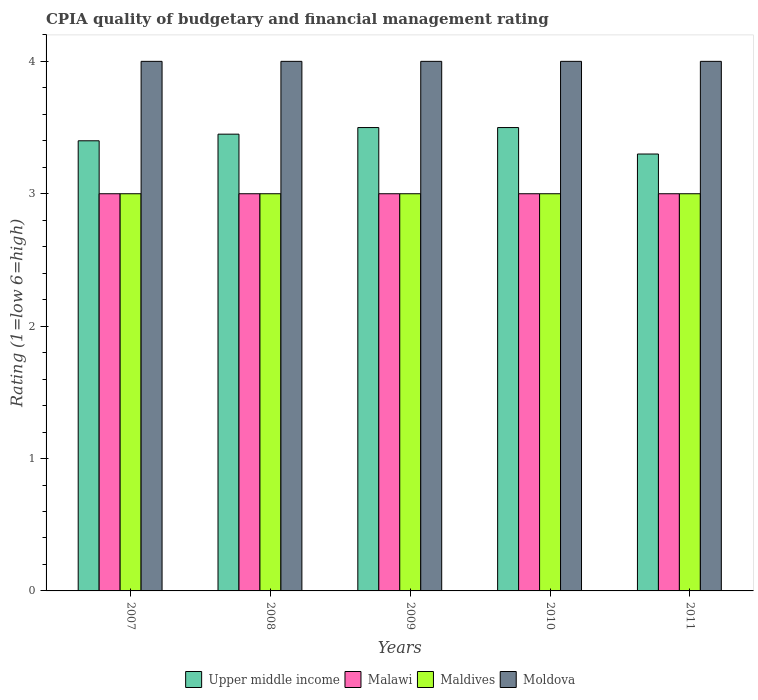Are the number of bars on each tick of the X-axis equal?
Ensure brevity in your answer.  Yes. How many bars are there on the 4th tick from the left?
Give a very brief answer. 4. Across all years, what is the maximum CPIA rating in Moldova?
Your answer should be compact. 4. In which year was the CPIA rating in Maldives maximum?
Offer a very short reply. 2007. In which year was the CPIA rating in Malawi minimum?
Make the answer very short. 2007. What is the difference between the CPIA rating in Maldives in 2008 and that in 2009?
Keep it short and to the point. 0. What is the average CPIA rating in Maldives per year?
Offer a terse response. 3. In how many years, is the CPIA rating in Maldives greater than 1?
Your answer should be very brief. 5. What is the difference between the highest and the lowest CPIA rating in Upper middle income?
Provide a succinct answer. 0.2. In how many years, is the CPIA rating in Moldova greater than the average CPIA rating in Moldova taken over all years?
Make the answer very short. 0. What does the 1st bar from the left in 2011 represents?
Your answer should be very brief. Upper middle income. What does the 4th bar from the right in 2011 represents?
Offer a terse response. Upper middle income. Are all the bars in the graph horizontal?
Your answer should be very brief. No. How many years are there in the graph?
Provide a short and direct response. 5. What is the difference between two consecutive major ticks on the Y-axis?
Offer a very short reply. 1. Does the graph contain any zero values?
Offer a very short reply. No. Does the graph contain grids?
Provide a succinct answer. No. Where does the legend appear in the graph?
Your response must be concise. Bottom center. How are the legend labels stacked?
Your response must be concise. Horizontal. What is the title of the graph?
Your response must be concise. CPIA quality of budgetary and financial management rating. Does "Luxembourg" appear as one of the legend labels in the graph?
Your answer should be compact. No. What is the Rating (1=low 6=high) in Maldives in 2007?
Your answer should be very brief. 3. What is the Rating (1=low 6=high) of Upper middle income in 2008?
Your answer should be compact. 3.45. What is the Rating (1=low 6=high) of Malawi in 2008?
Give a very brief answer. 3. What is the Rating (1=low 6=high) of Maldives in 2009?
Offer a very short reply. 3. What is the Rating (1=low 6=high) of Moldova in 2009?
Provide a succinct answer. 4. What is the Rating (1=low 6=high) of Malawi in 2010?
Offer a very short reply. 3. What is the Rating (1=low 6=high) of Maldives in 2010?
Offer a very short reply. 3. What is the Rating (1=low 6=high) of Moldova in 2010?
Give a very brief answer. 4. What is the Rating (1=low 6=high) in Upper middle income in 2011?
Offer a very short reply. 3.3. What is the Rating (1=low 6=high) of Maldives in 2011?
Your answer should be compact. 3. What is the Rating (1=low 6=high) in Moldova in 2011?
Your answer should be very brief. 4. Across all years, what is the maximum Rating (1=low 6=high) in Malawi?
Offer a terse response. 3. Across all years, what is the minimum Rating (1=low 6=high) of Upper middle income?
Offer a terse response. 3.3. Across all years, what is the minimum Rating (1=low 6=high) in Maldives?
Give a very brief answer. 3. What is the total Rating (1=low 6=high) of Upper middle income in the graph?
Provide a short and direct response. 17.15. What is the total Rating (1=low 6=high) of Malawi in the graph?
Provide a succinct answer. 15. What is the difference between the Rating (1=low 6=high) in Malawi in 2007 and that in 2008?
Keep it short and to the point. 0. What is the difference between the Rating (1=low 6=high) of Maldives in 2007 and that in 2008?
Ensure brevity in your answer.  0. What is the difference between the Rating (1=low 6=high) in Moldova in 2007 and that in 2008?
Provide a succinct answer. 0. What is the difference between the Rating (1=low 6=high) in Moldova in 2007 and that in 2009?
Your answer should be compact. 0. What is the difference between the Rating (1=low 6=high) in Upper middle income in 2007 and that in 2010?
Offer a terse response. -0.1. What is the difference between the Rating (1=low 6=high) in Malawi in 2007 and that in 2010?
Keep it short and to the point. 0. What is the difference between the Rating (1=low 6=high) in Maldives in 2007 and that in 2010?
Keep it short and to the point. 0. What is the difference between the Rating (1=low 6=high) in Moldova in 2007 and that in 2010?
Your answer should be compact. 0. What is the difference between the Rating (1=low 6=high) of Malawi in 2007 and that in 2011?
Your answer should be compact. 0. What is the difference between the Rating (1=low 6=high) of Moldova in 2007 and that in 2011?
Make the answer very short. 0. What is the difference between the Rating (1=low 6=high) in Malawi in 2008 and that in 2010?
Offer a very short reply. 0. What is the difference between the Rating (1=low 6=high) of Upper middle income in 2008 and that in 2011?
Give a very brief answer. 0.15. What is the difference between the Rating (1=low 6=high) in Malawi in 2008 and that in 2011?
Offer a terse response. 0. What is the difference between the Rating (1=low 6=high) in Maldives in 2008 and that in 2011?
Keep it short and to the point. 0. What is the difference between the Rating (1=low 6=high) in Maldives in 2009 and that in 2010?
Offer a very short reply. 0. What is the difference between the Rating (1=low 6=high) in Moldova in 2009 and that in 2010?
Keep it short and to the point. 0. What is the difference between the Rating (1=low 6=high) of Upper middle income in 2009 and that in 2011?
Give a very brief answer. 0.2. What is the difference between the Rating (1=low 6=high) of Malawi in 2009 and that in 2011?
Make the answer very short. 0. What is the difference between the Rating (1=low 6=high) in Maldives in 2009 and that in 2011?
Your answer should be very brief. 0. What is the difference between the Rating (1=low 6=high) in Moldova in 2009 and that in 2011?
Make the answer very short. 0. What is the difference between the Rating (1=low 6=high) in Maldives in 2010 and that in 2011?
Keep it short and to the point. 0. What is the difference between the Rating (1=low 6=high) of Upper middle income in 2007 and the Rating (1=low 6=high) of Malawi in 2008?
Your answer should be very brief. 0.4. What is the difference between the Rating (1=low 6=high) of Upper middle income in 2007 and the Rating (1=low 6=high) of Moldova in 2009?
Your answer should be compact. -0.6. What is the difference between the Rating (1=low 6=high) in Maldives in 2007 and the Rating (1=low 6=high) in Moldova in 2009?
Your answer should be very brief. -1. What is the difference between the Rating (1=low 6=high) of Upper middle income in 2007 and the Rating (1=low 6=high) of Maldives in 2010?
Your answer should be compact. 0.4. What is the difference between the Rating (1=low 6=high) of Upper middle income in 2007 and the Rating (1=low 6=high) of Malawi in 2011?
Make the answer very short. 0.4. What is the difference between the Rating (1=low 6=high) in Malawi in 2007 and the Rating (1=low 6=high) in Moldova in 2011?
Offer a very short reply. -1. What is the difference between the Rating (1=low 6=high) of Upper middle income in 2008 and the Rating (1=low 6=high) of Malawi in 2009?
Offer a terse response. 0.45. What is the difference between the Rating (1=low 6=high) of Upper middle income in 2008 and the Rating (1=low 6=high) of Maldives in 2009?
Your response must be concise. 0.45. What is the difference between the Rating (1=low 6=high) of Upper middle income in 2008 and the Rating (1=low 6=high) of Moldova in 2009?
Keep it short and to the point. -0.55. What is the difference between the Rating (1=low 6=high) in Malawi in 2008 and the Rating (1=low 6=high) in Maldives in 2009?
Offer a very short reply. 0. What is the difference between the Rating (1=low 6=high) of Upper middle income in 2008 and the Rating (1=low 6=high) of Malawi in 2010?
Ensure brevity in your answer.  0.45. What is the difference between the Rating (1=low 6=high) of Upper middle income in 2008 and the Rating (1=low 6=high) of Maldives in 2010?
Provide a short and direct response. 0.45. What is the difference between the Rating (1=low 6=high) of Upper middle income in 2008 and the Rating (1=low 6=high) of Moldova in 2010?
Provide a succinct answer. -0.55. What is the difference between the Rating (1=low 6=high) of Malawi in 2008 and the Rating (1=low 6=high) of Maldives in 2010?
Provide a succinct answer. 0. What is the difference between the Rating (1=low 6=high) in Malawi in 2008 and the Rating (1=low 6=high) in Moldova in 2010?
Provide a short and direct response. -1. What is the difference between the Rating (1=low 6=high) in Upper middle income in 2008 and the Rating (1=low 6=high) in Malawi in 2011?
Keep it short and to the point. 0.45. What is the difference between the Rating (1=low 6=high) in Upper middle income in 2008 and the Rating (1=low 6=high) in Maldives in 2011?
Your answer should be compact. 0.45. What is the difference between the Rating (1=low 6=high) of Upper middle income in 2008 and the Rating (1=low 6=high) of Moldova in 2011?
Your answer should be very brief. -0.55. What is the difference between the Rating (1=low 6=high) of Malawi in 2008 and the Rating (1=low 6=high) of Maldives in 2011?
Keep it short and to the point. 0. What is the difference between the Rating (1=low 6=high) in Malawi in 2008 and the Rating (1=low 6=high) in Moldova in 2011?
Provide a succinct answer. -1. What is the difference between the Rating (1=low 6=high) in Maldives in 2008 and the Rating (1=low 6=high) in Moldova in 2011?
Your answer should be compact. -1. What is the difference between the Rating (1=low 6=high) in Upper middle income in 2009 and the Rating (1=low 6=high) in Malawi in 2010?
Your answer should be very brief. 0.5. What is the difference between the Rating (1=low 6=high) of Malawi in 2009 and the Rating (1=low 6=high) of Moldova in 2010?
Your response must be concise. -1. What is the difference between the Rating (1=low 6=high) of Upper middle income in 2009 and the Rating (1=low 6=high) of Moldova in 2011?
Provide a succinct answer. -0.5. What is the difference between the Rating (1=low 6=high) in Maldives in 2009 and the Rating (1=low 6=high) in Moldova in 2011?
Keep it short and to the point. -1. What is the difference between the Rating (1=low 6=high) of Upper middle income in 2010 and the Rating (1=low 6=high) of Malawi in 2011?
Provide a short and direct response. 0.5. What is the difference between the Rating (1=low 6=high) of Malawi in 2010 and the Rating (1=low 6=high) of Maldives in 2011?
Make the answer very short. 0. What is the difference between the Rating (1=low 6=high) of Malawi in 2010 and the Rating (1=low 6=high) of Moldova in 2011?
Make the answer very short. -1. What is the average Rating (1=low 6=high) in Upper middle income per year?
Your answer should be very brief. 3.43. What is the average Rating (1=low 6=high) of Maldives per year?
Offer a terse response. 3. In the year 2007, what is the difference between the Rating (1=low 6=high) of Upper middle income and Rating (1=low 6=high) of Malawi?
Provide a short and direct response. 0.4. In the year 2007, what is the difference between the Rating (1=low 6=high) in Upper middle income and Rating (1=low 6=high) in Maldives?
Give a very brief answer. 0.4. In the year 2007, what is the difference between the Rating (1=low 6=high) in Malawi and Rating (1=low 6=high) in Maldives?
Keep it short and to the point. 0. In the year 2007, what is the difference between the Rating (1=low 6=high) in Malawi and Rating (1=low 6=high) in Moldova?
Provide a short and direct response. -1. In the year 2007, what is the difference between the Rating (1=low 6=high) in Maldives and Rating (1=low 6=high) in Moldova?
Provide a short and direct response. -1. In the year 2008, what is the difference between the Rating (1=low 6=high) of Upper middle income and Rating (1=low 6=high) of Malawi?
Your answer should be very brief. 0.45. In the year 2008, what is the difference between the Rating (1=low 6=high) of Upper middle income and Rating (1=low 6=high) of Maldives?
Keep it short and to the point. 0.45. In the year 2008, what is the difference between the Rating (1=low 6=high) of Upper middle income and Rating (1=low 6=high) of Moldova?
Give a very brief answer. -0.55. In the year 2008, what is the difference between the Rating (1=low 6=high) of Malawi and Rating (1=low 6=high) of Maldives?
Offer a very short reply. 0. In the year 2008, what is the difference between the Rating (1=low 6=high) of Maldives and Rating (1=low 6=high) of Moldova?
Offer a very short reply. -1. In the year 2009, what is the difference between the Rating (1=low 6=high) in Malawi and Rating (1=low 6=high) in Moldova?
Provide a succinct answer. -1. In the year 2011, what is the difference between the Rating (1=low 6=high) of Upper middle income and Rating (1=low 6=high) of Malawi?
Give a very brief answer. 0.3. In the year 2011, what is the difference between the Rating (1=low 6=high) in Malawi and Rating (1=low 6=high) in Moldova?
Make the answer very short. -1. What is the ratio of the Rating (1=low 6=high) of Upper middle income in 2007 to that in 2008?
Offer a terse response. 0.99. What is the ratio of the Rating (1=low 6=high) of Moldova in 2007 to that in 2008?
Make the answer very short. 1. What is the ratio of the Rating (1=low 6=high) of Upper middle income in 2007 to that in 2009?
Your answer should be very brief. 0.97. What is the ratio of the Rating (1=low 6=high) of Malawi in 2007 to that in 2009?
Give a very brief answer. 1. What is the ratio of the Rating (1=low 6=high) in Upper middle income in 2007 to that in 2010?
Keep it short and to the point. 0.97. What is the ratio of the Rating (1=low 6=high) of Maldives in 2007 to that in 2010?
Your answer should be very brief. 1. What is the ratio of the Rating (1=low 6=high) in Upper middle income in 2007 to that in 2011?
Your answer should be compact. 1.03. What is the ratio of the Rating (1=low 6=high) of Malawi in 2007 to that in 2011?
Offer a terse response. 1. What is the ratio of the Rating (1=low 6=high) of Maldives in 2007 to that in 2011?
Provide a succinct answer. 1. What is the ratio of the Rating (1=low 6=high) in Moldova in 2007 to that in 2011?
Your answer should be very brief. 1. What is the ratio of the Rating (1=low 6=high) of Upper middle income in 2008 to that in 2009?
Provide a succinct answer. 0.99. What is the ratio of the Rating (1=low 6=high) in Malawi in 2008 to that in 2009?
Give a very brief answer. 1. What is the ratio of the Rating (1=low 6=high) of Maldives in 2008 to that in 2009?
Offer a very short reply. 1. What is the ratio of the Rating (1=low 6=high) of Upper middle income in 2008 to that in 2010?
Give a very brief answer. 0.99. What is the ratio of the Rating (1=low 6=high) in Malawi in 2008 to that in 2010?
Offer a very short reply. 1. What is the ratio of the Rating (1=low 6=high) of Moldova in 2008 to that in 2010?
Your response must be concise. 1. What is the ratio of the Rating (1=low 6=high) of Upper middle income in 2008 to that in 2011?
Keep it short and to the point. 1.05. What is the ratio of the Rating (1=low 6=high) in Malawi in 2008 to that in 2011?
Your response must be concise. 1. What is the ratio of the Rating (1=low 6=high) in Maldives in 2008 to that in 2011?
Your answer should be very brief. 1. What is the ratio of the Rating (1=low 6=high) in Upper middle income in 2009 to that in 2010?
Your answer should be very brief. 1. What is the ratio of the Rating (1=low 6=high) of Malawi in 2009 to that in 2010?
Offer a terse response. 1. What is the ratio of the Rating (1=low 6=high) in Maldives in 2009 to that in 2010?
Provide a short and direct response. 1. What is the ratio of the Rating (1=low 6=high) of Upper middle income in 2009 to that in 2011?
Offer a terse response. 1.06. What is the ratio of the Rating (1=low 6=high) in Malawi in 2009 to that in 2011?
Your answer should be compact. 1. What is the ratio of the Rating (1=low 6=high) in Maldives in 2009 to that in 2011?
Provide a succinct answer. 1. What is the ratio of the Rating (1=low 6=high) in Upper middle income in 2010 to that in 2011?
Offer a very short reply. 1.06. What is the difference between the highest and the second highest Rating (1=low 6=high) of Malawi?
Offer a very short reply. 0. What is the difference between the highest and the second highest Rating (1=low 6=high) in Maldives?
Offer a terse response. 0. What is the difference between the highest and the second highest Rating (1=low 6=high) of Moldova?
Your response must be concise. 0. What is the difference between the highest and the lowest Rating (1=low 6=high) of Moldova?
Keep it short and to the point. 0. 